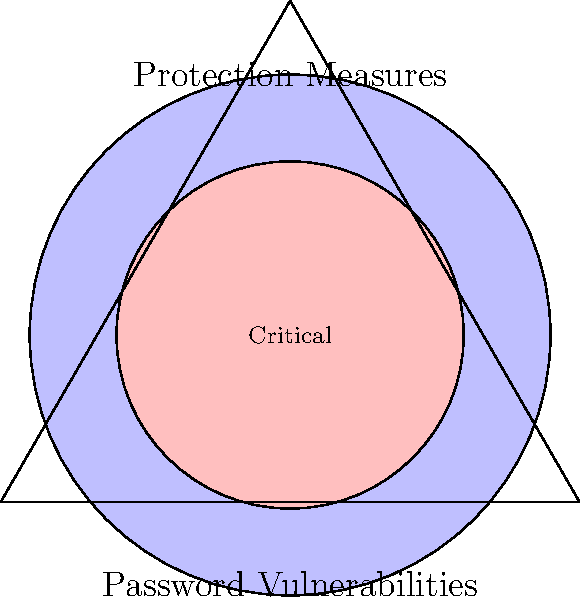In the Venn diagram representing password vulnerabilities and protection measures for your password management app, the outer circle represents all password vulnerabilities, while the inner circle represents critical vulnerabilities that require immediate attention. If the area of the equilateral triangle is $\sqrt{3}$ square units, what is the area of the region representing non-critical vulnerabilities (blue region minus red region)? Let's approach this step-by-step:

1) First, we need to find the side length of the equilateral triangle. We know that the area of an equilateral triangle is given by:

   $A = \frac{\sqrt{3}}{4}a^2$

   Where $a$ is the side length. We're given that $A = \sqrt{3}$, so:

   $\sqrt{3} = \frac{\sqrt{3}}{4}a^2$
   $a^2 = 4$
   $a = 2$

2) The radius of the outer circle (representing all vulnerabilities) is the height of the triangle, which is:

   $h = \frac{\sqrt{3}}{2}a = \frac{\sqrt{3}}{2} * 2 = \sqrt{3}$

3) The radius of the inner circle (critical vulnerabilities) is $\frac{2}{3}$ of the outer circle's radius:

   $r_{inner} = \frac{2}{3}\sqrt{3} = \frac{2\sqrt{3}}{3}$

4) The area of the outer circle is:

   $A_{outer} = \pi r^2 = \pi * (\sqrt{3})^2 = 3\pi$

5) The area of the inner circle is:

   $A_{inner} = \pi r^2 = \pi * (\frac{2\sqrt{3}}{3})^2 = \frac{4\pi}{3}$

6) The area of non-critical vulnerabilities is the difference between these areas:

   $A_{non-critical} = A_{outer} - A_{inner} = 3\pi - \frac{4\pi}{3} = \frac{5\pi}{3}$

Therefore, the area representing non-critical vulnerabilities is $\frac{5\pi}{3}$ square units.
Answer: $\frac{5\pi}{3}$ square units 